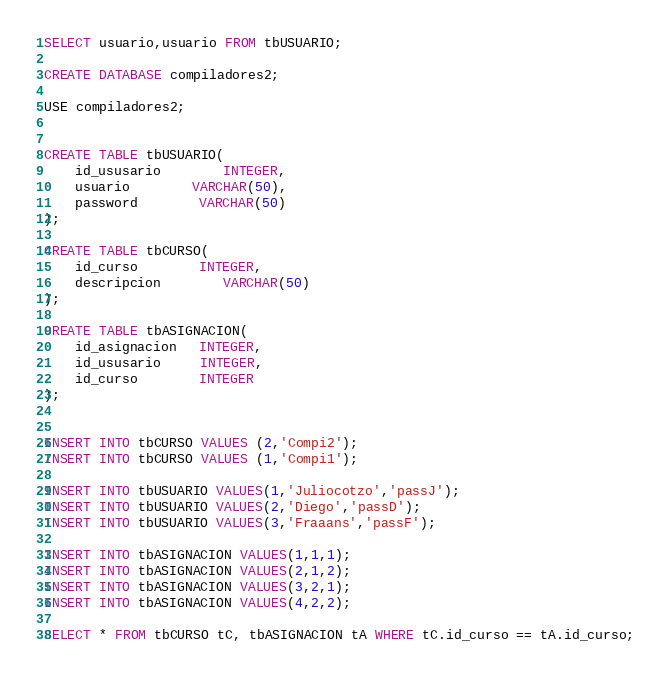Convert code to text. <code><loc_0><loc_0><loc_500><loc_500><_SQL_>





SELECT usuario,usuario FROM tbUSUARIO;

CREATE DATABASE compiladores2;

USE compiladores2;


CREATE TABLE tbUSUARIO(
	id_ususario		INTEGER,
	usuario		VARCHAR(50),
	password		VARCHAR(50)
);

CREATE TABLE tbCURSO(
	id_curso		INTEGER,
	descripcion		VARCHAR(50)
);

CREATE TABLE tbASIGNACION(
    id_asignacion   INTEGER,
    id_ususario     INTEGER,
    id_curso        INTEGER
);


INSERT INTO tbCURSO VALUES (2,'Compi2');
INSERT INTO tbCURSO VALUES (1,'Compi1');

INSERT INTO tbUSUARIO VALUES(1,'Juliocotzo','passJ');
INSERT INTO tbUSUARIO VALUES(2,'Diego','passD');
INSERT INTO tbUSUARIO VALUES(3,'Fraaans','passF');

INSERT INTO tbASIGNACION VALUES(1,1,1);
INSERT INTO tbASIGNACION VALUES(2,1,2);
INSERT INTO tbASIGNACION VALUES(3,2,1);
INSERT INTO tbASIGNACION VALUES(4,2,2);

SELECT * FROM tbCURSO tC, tbASIGNACION tA WHERE tC.id_curso == tA.id_curso;</code> 